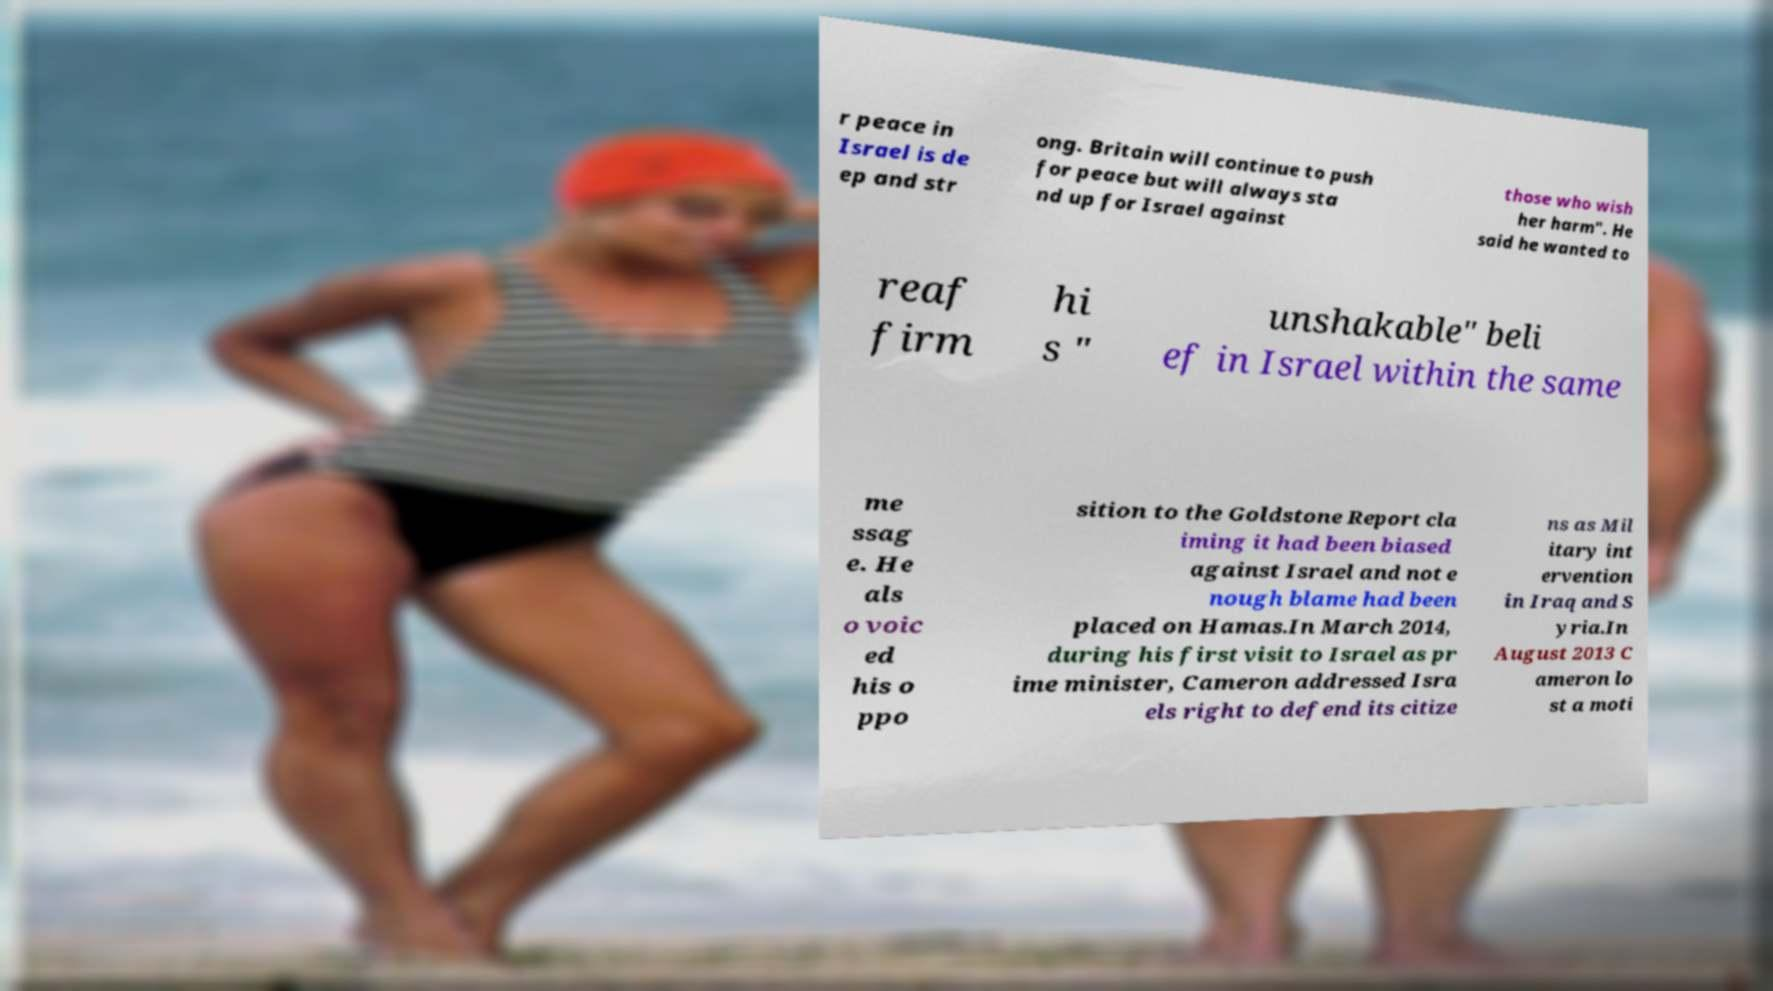Please identify and transcribe the text found in this image. r peace in Israel is de ep and str ong. Britain will continue to push for peace but will always sta nd up for Israel against those who wish her harm". He said he wanted to reaf firm hi s " unshakable" beli ef in Israel within the same me ssag e. He als o voic ed his o ppo sition to the Goldstone Report cla iming it had been biased against Israel and not e nough blame had been placed on Hamas.In March 2014, during his first visit to Israel as pr ime minister, Cameron addressed Isra els right to defend its citize ns as Mil itary int ervention in Iraq and S yria.In August 2013 C ameron lo st a moti 